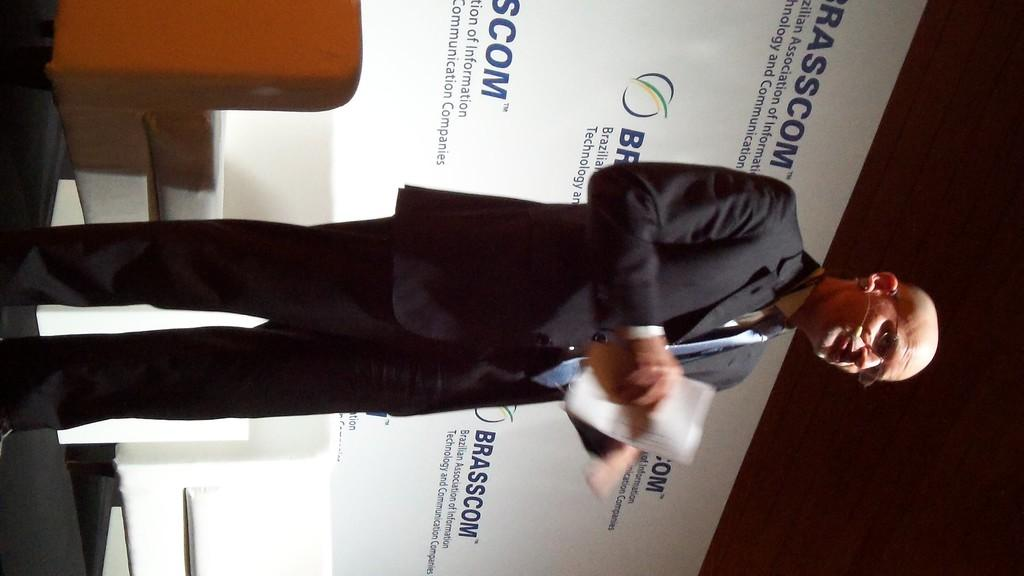Who is the main subject in the image? There is a man in the middle of the image. What is the man wearing? The man is wearing a coat and spectacles. What type of furniture is on the left side of the image? There are sofas on the left side of the image. What can be seen in the background of the image? There is a banner in the background of the image. What is the value of the rice being served on the table in the image? There is no rice or table present in the image; it features a man wearing a coat and spectacles, sofas on the left side, and a banner in the background. 